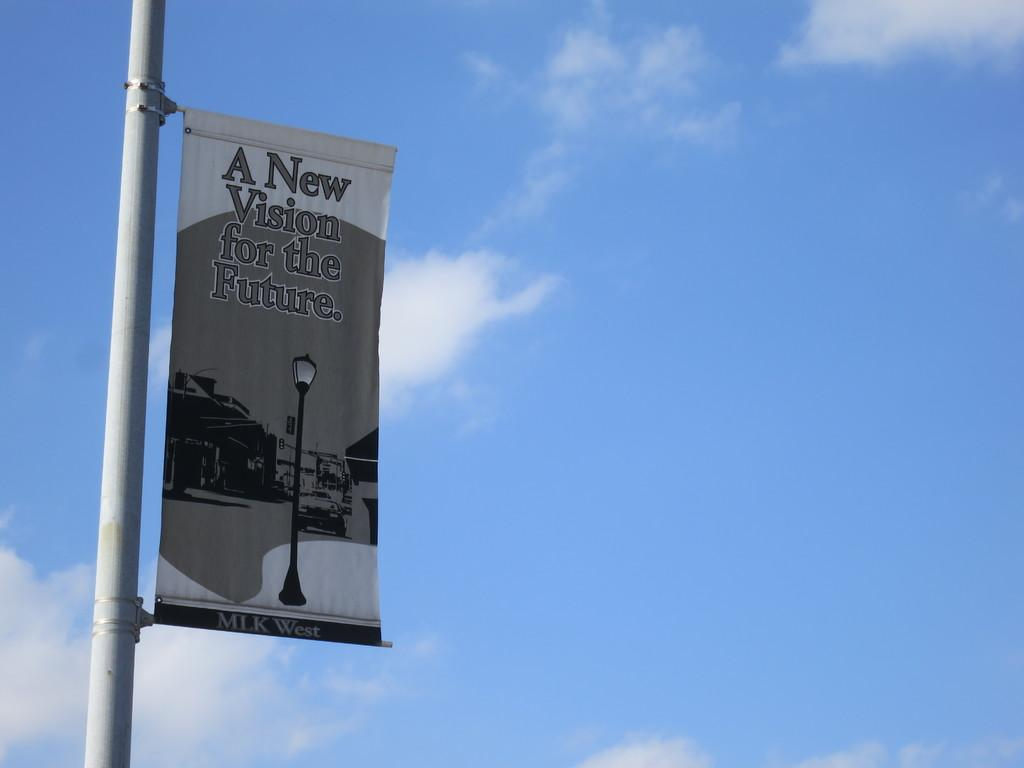Provide a one-sentence caption for the provided image. A tarpaulin with a message "A new Vision for the Future". 